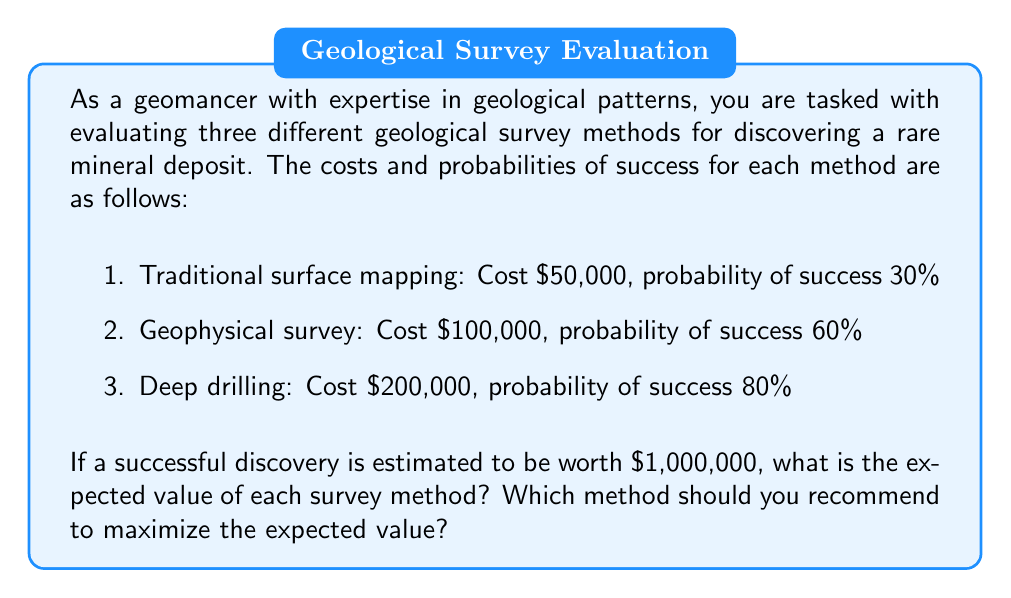Help me with this question. To solve this problem, we need to calculate the expected value for each survey method and compare them. The expected value is calculated by subtracting the cost of the survey from the product of the probability of success and the value of a successful discovery.

Let's calculate the expected value for each method:

1. Traditional surface mapping:
   $$ EV_1 = (0.30 \times \$1,000,000) - \$50,000 = \$300,000 - \$50,000 = \$250,000 $$

2. Geophysical survey:
   $$ EV_2 = (0.60 \times \$1,000,000) - \$100,000 = \$600,000 - \$100,000 = \$500,000 $$

3. Deep drilling:
   $$ EV_3 = (0.80 \times \$1,000,000) - \$200,000 = \$800,000 - \$200,000 = \$600,000 $$

To visualize the comparison:

[asy]
size(200,150);
real[] EV = {250000, 500000, 600000};
string[] labels = {"Surface mapping", "Geophysical", "Deep drilling"};
for (int i=0; i<3; ++i) {
  draw((i,0)--(i,EV[i]/10000), blue+1);
  label(labels[i], (i,-5), S);
  label(format("$%,d", EV[i]), (i,EV[i]/10000), N);
}
xaxis("Survey method", Bottom, NoTicks);
yaxis("Expected Value ($)", Left, RightTicks);
[/asy]

Comparing the expected values:
$$ EV_3 > EV_2 > EV_1 $$

The deep drilling method has the highest expected value, followed by the geophysical survey, and then traditional surface mapping.
Answer: The expected values for each method are:
1. Traditional surface mapping: $250,000
2. Geophysical survey: $500,000
3. Deep drilling: $600,000

The deep drilling method should be recommended as it maximizes the expected value at $600,000. 